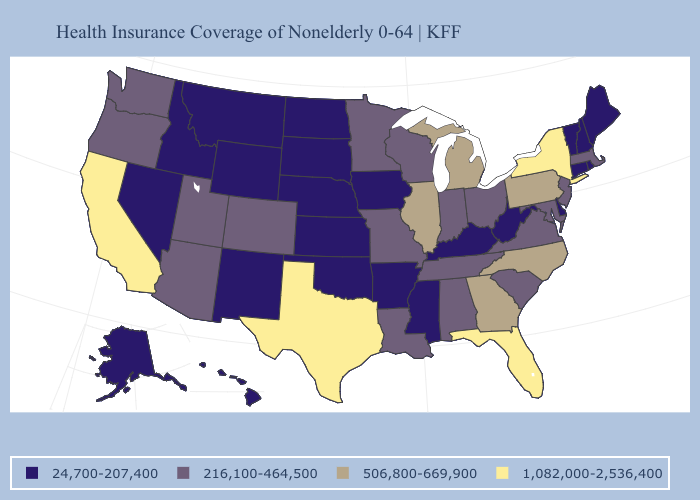Name the states that have a value in the range 24,700-207,400?
Write a very short answer. Alaska, Arkansas, Connecticut, Delaware, Hawaii, Idaho, Iowa, Kansas, Kentucky, Maine, Mississippi, Montana, Nebraska, Nevada, New Hampshire, New Mexico, North Dakota, Oklahoma, Rhode Island, South Dakota, Vermont, West Virginia, Wyoming. Does Oklahoma have the lowest value in the South?
Quick response, please. Yes. What is the value of California?
Answer briefly. 1,082,000-2,536,400. How many symbols are there in the legend?
Write a very short answer. 4. What is the value of Maine?
Answer briefly. 24,700-207,400. What is the highest value in the USA?
Concise answer only. 1,082,000-2,536,400. Name the states that have a value in the range 1,082,000-2,536,400?
Short answer required. California, Florida, New York, Texas. Which states have the lowest value in the USA?
Write a very short answer. Alaska, Arkansas, Connecticut, Delaware, Hawaii, Idaho, Iowa, Kansas, Kentucky, Maine, Mississippi, Montana, Nebraska, Nevada, New Hampshire, New Mexico, North Dakota, Oklahoma, Rhode Island, South Dakota, Vermont, West Virginia, Wyoming. Which states hav the highest value in the MidWest?
Concise answer only. Illinois, Michigan. What is the value of Wyoming?
Be succinct. 24,700-207,400. What is the lowest value in the West?
Quick response, please. 24,700-207,400. Does Kentucky have the lowest value in the South?
Concise answer only. Yes. Among the states that border Missouri , which have the highest value?
Write a very short answer. Illinois. What is the highest value in states that border Delaware?
Give a very brief answer. 506,800-669,900. Does Indiana have the lowest value in the MidWest?
Keep it brief. No. 